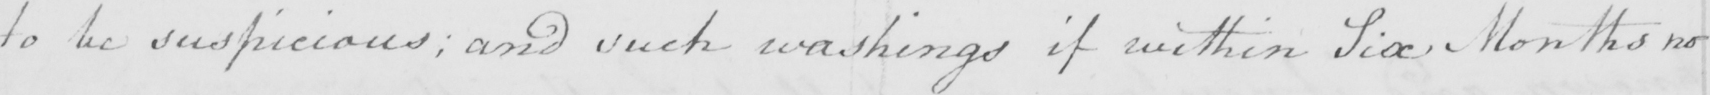What does this handwritten line say? to be suspicious ; and such washings if within Six Months no 